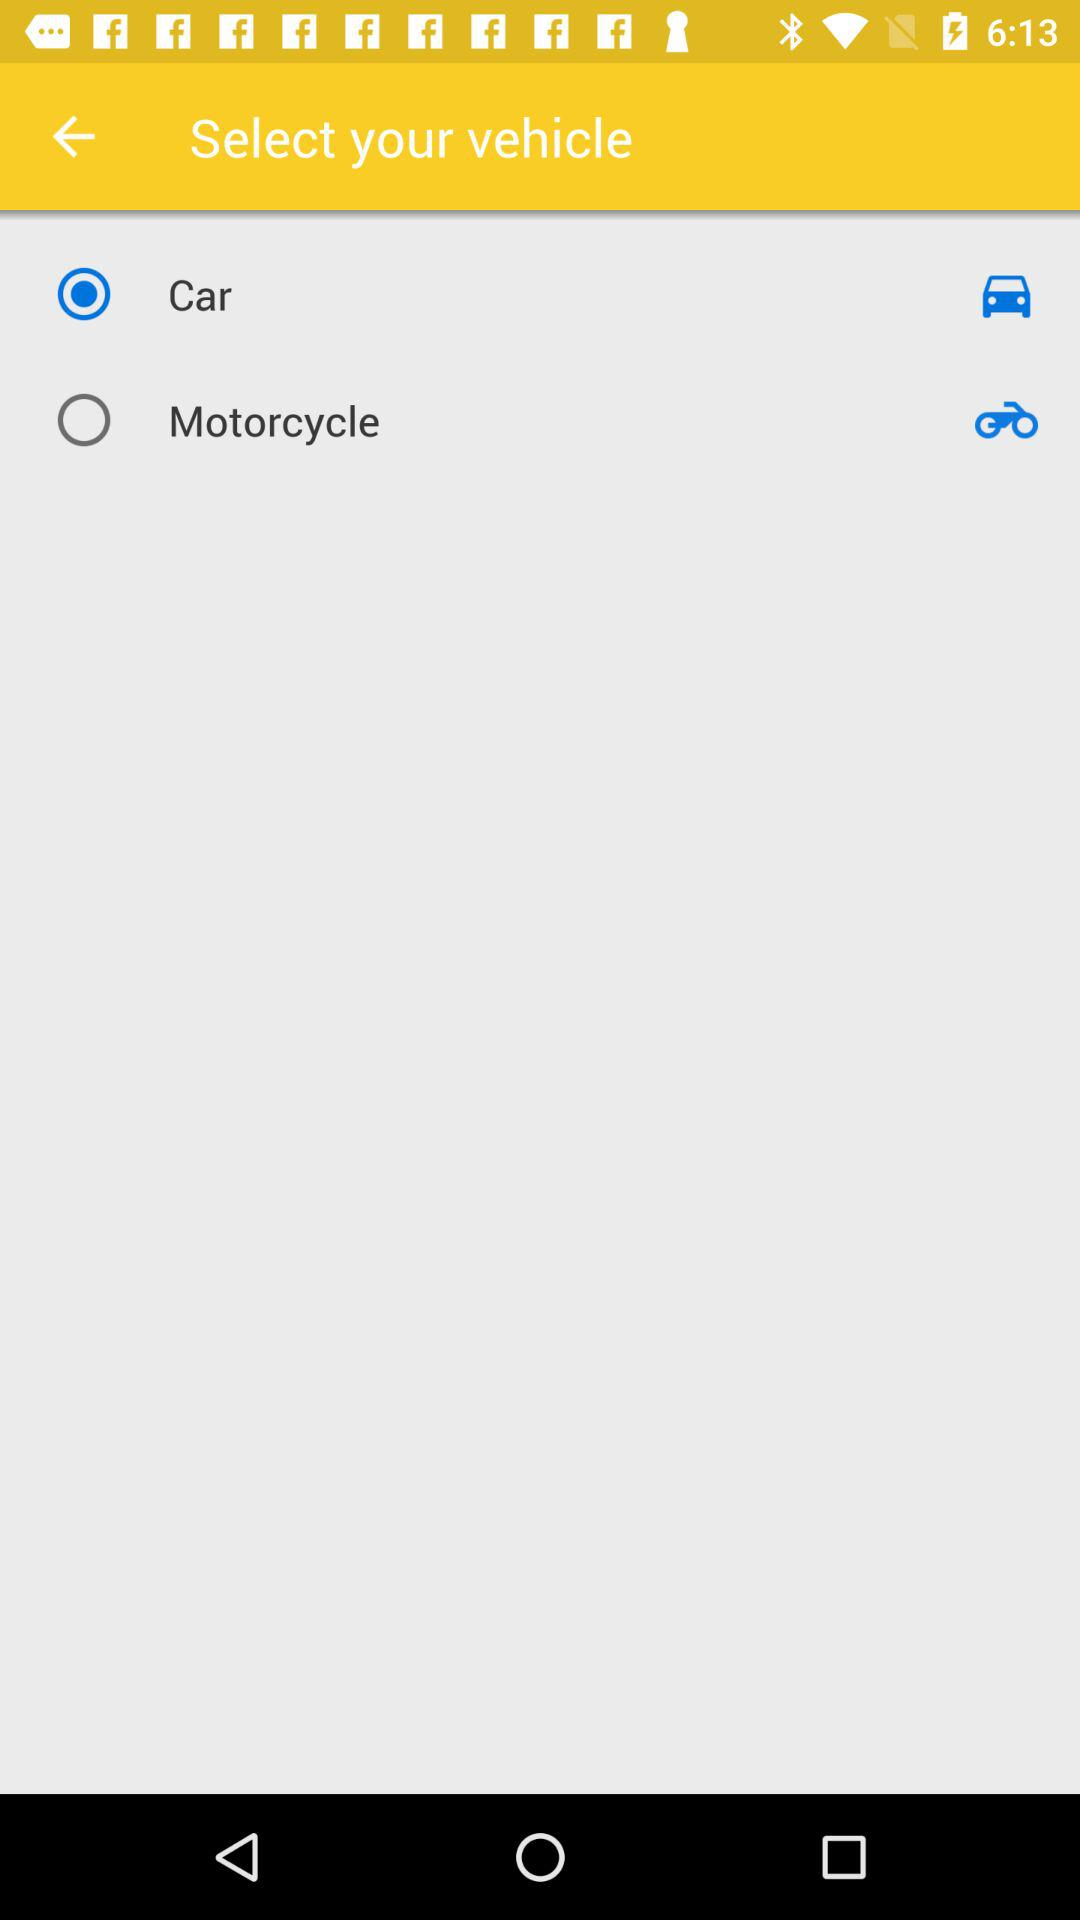How many vehicle types are available?
Answer the question using a single word or phrase. 2 